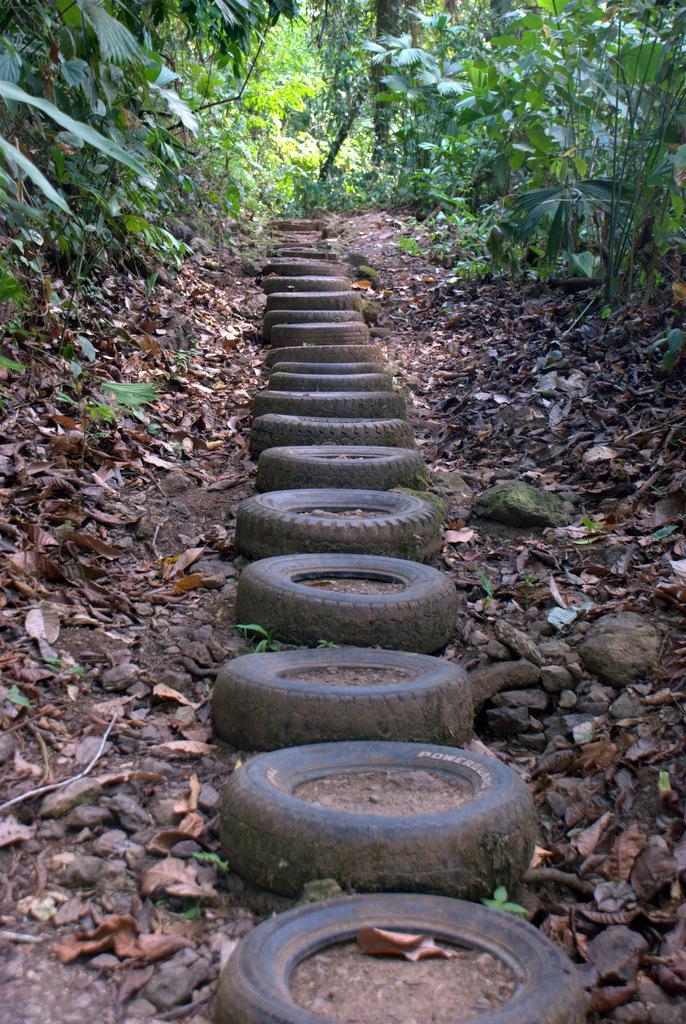How would you summarize this image in a sentence or two? In this image we can see tyres, shredded leaves, stones and plants. 